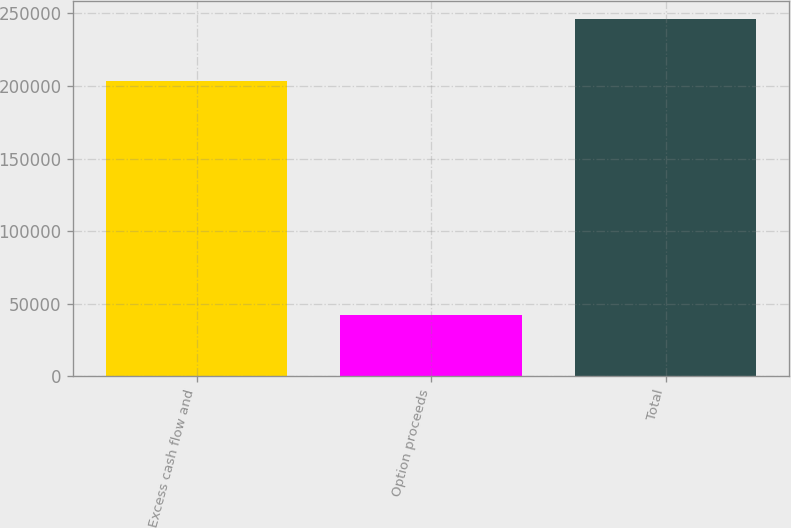Convert chart to OTSL. <chart><loc_0><loc_0><loc_500><loc_500><bar_chart><fcel>Excess cash flow and<fcel>Option proceeds<fcel>Total<nl><fcel>203566<fcel>42440<fcel>246006<nl></chart> 